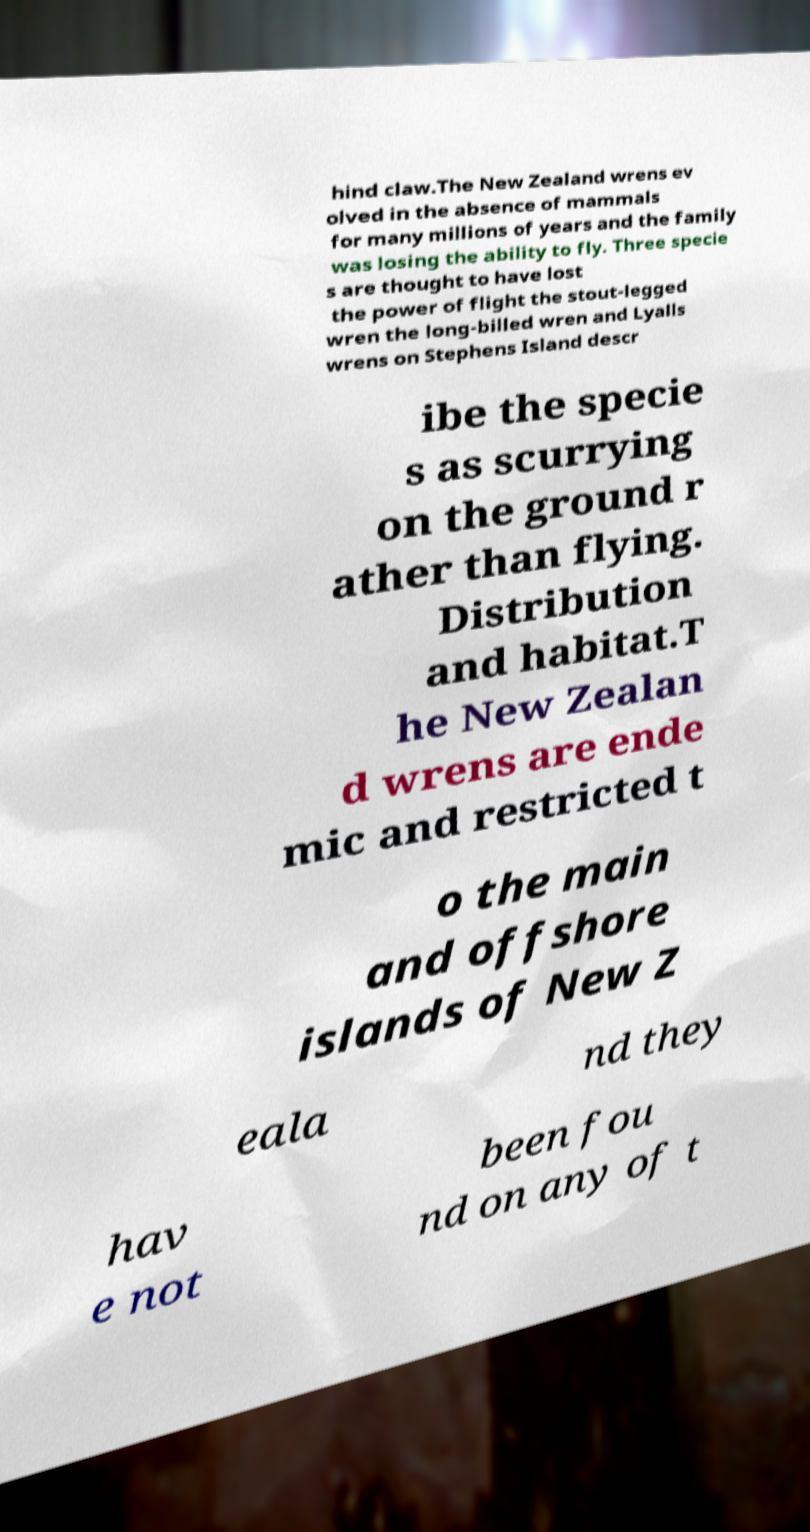Could you extract and type out the text from this image? hind claw.The New Zealand wrens ev olved in the absence of mammals for many millions of years and the family was losing the ability to fly. Three specie s are thought to have lost the power of flight the stout-legged wren the long-billed wren and Lyalls wrens on Stephens Island descr ibe the specie s as scurrying on the ground r ather than flying. Distribution and habitat.T he New Zealan d wrens are ende mic and restricted t o the main and offshore islands of New Z eala nd they hav e not been fou nd on any of t 